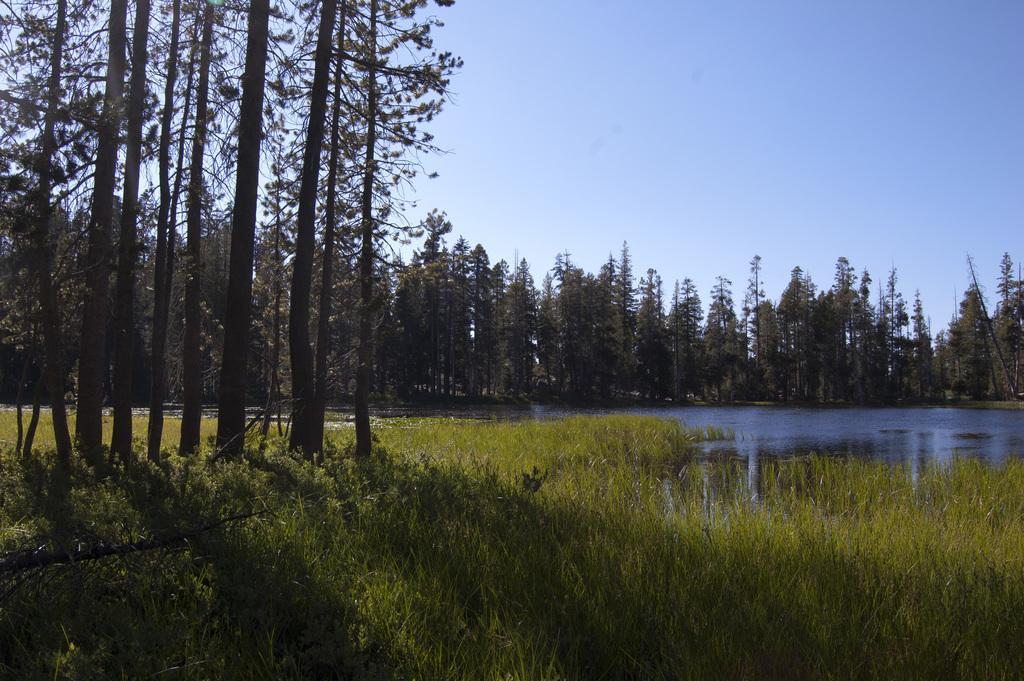Please provide a concise description of this image. In this image I can see a green color grass and trees. We can see water. The sky is in blue and white color. 